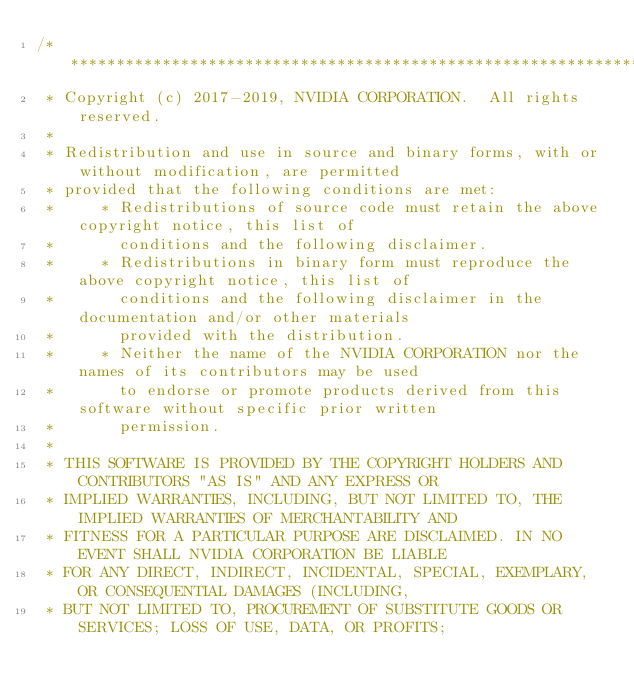<code> <loc_0><loc_0><loc_500><loc_500><_Cuda_>/***************************************************************************************************
 * Copyright (c) 2017-2019, NVIDIA CORPORATION.  All rights reserved.
 *
 * Redistribution and use in source and binary forms, with or without modification, are permitted
 * provided that the following conditions are met:
 *     * Redistributions of source code must retain the above copyright notice, this list of
 *       conditions and the following disclaimer.
 *     * Redistributions in binary form must reproduce the above copyright notice, this list of
 *       conditions and the following disclaimer in the documentation and/or other materials
 *       provided with the distribution.
 *     * Neither the name of the NVIDIA CORPORATION nor the names of its contributors may be used
 *       to endorse or promote products derived from this software without specific prior written
 *       permission.
 *
 * THIS SOFTWARE IS PROVIDED BY THE COPYRIGHT HOLDERS AND CONTRIBUTORS "AS IS" AND ANY EXPRESS OR
 * IMPLIED WARRANTIES, INCLUDING, BUT NOT LIMITED TO, THE IMPLIED WARRANTIES OF MERCHANTABILITY AND
 * FITNESS FOR A PARTICULAR PURPOSE ARE DISCLAIMED. IN NO EVENT SHALL NVIDIA CORPORATION BE LIABLE
 * FOR ANY DIRECT, INDIRECT, INCIDENTAL, SPECIAL, EXEMPLARY, OR CONSEQUENTIAL DAMAGES (INCLUDING,
 * BUT NOT LIMITED TO, PROCUREMENT OF SUBSTITUTE GOODS OR SERVICES; LOSS OF USE, DATA, OR PROFITS;</code> 